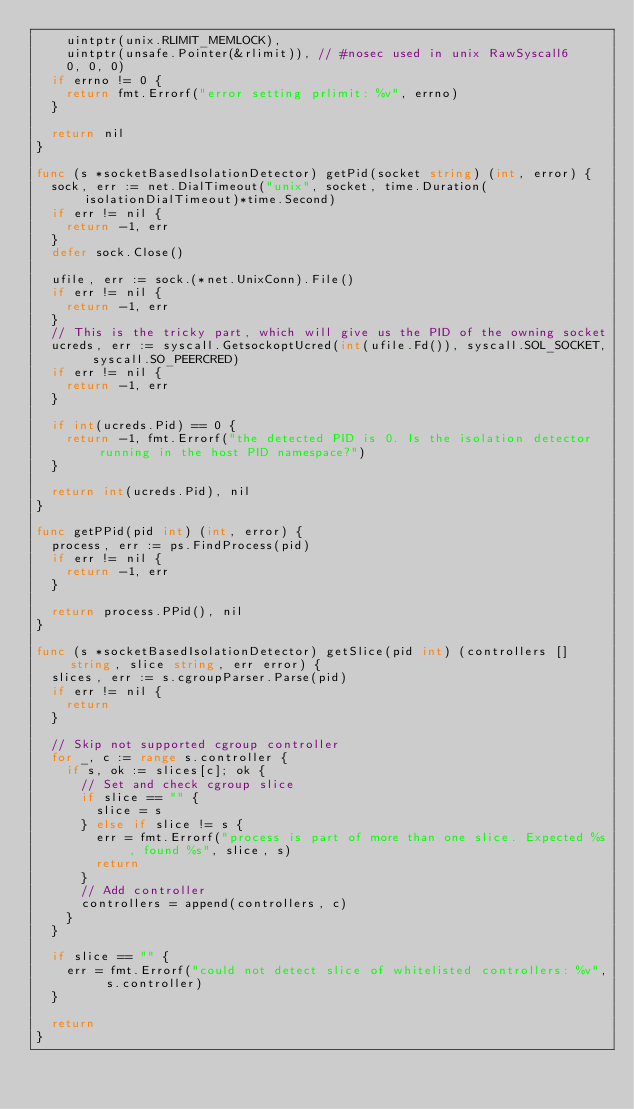Convert code to text. <code><loc_0><loc_0><loc_500><loc_500><_Go_>		uintptr(unix.RLIMIT_MEMLOCK),
		uintptr(unsafe.Pointer(&rlimit)), // #nosec used in unix RawSyscall6
		0, 0, 0)
	if errno != 0 {
		return fmt.Errorf("error setting prlimit: %v", errno)
	}

	return nil
}

func (s *socketBasedIsolationDetector) getPid(socket string) (int, error) {
	sock, err := net.DialTimeout("unix", socket, time.Duration(isolationDialTimeout)*time.Second)
	if err != nil {
		return -1, err
	}
	defer sock.Close()

	ufile, err := sock.(*net.UnixConn).File()
	if err != nil {
		return -1, err
	}
	// This is the tricky part, which will give us the PID of the owning socket
	ucreds, err := syscall.GetsockoptUcred(int(ufile.Fd()), syscall.SOL_SOCKET, syscall.SO_PEERCRED)
	if err != nil {
		return -1, err
	}

	if int(ucreds.Pid) == 0 {
		return -1, fmt.Errorf("the detected PID is 0. Is the isolation detector running in the host PID namespace?")
	}

	return int(ucreds.Pid), nil
}

func getPPid(pid int) (int, error) {
	process, err := ps.FindProcess(pid)
	if err != nil {
		return -1, err
	}

	return process.PPid(), nil
}

func (s *socketBasedIsolationDetector) getSlice(pid int) (controllers []string, slice string, err error) {
	slices, err := s.cgroupParser.Parse(pid)
	if err != nil {
		return
	}

	// Skip not supported cgroup controller
	for _, c := range s.controller {
		if s, ok := slices[c]; ok {
			// Set and check cgroup slice
			if slice == "" {
				slice = s
			} else if slice != s {
				err = fmt.Errorf("process is part of more than one slice. Expected %s, found %s", slice, s)
				return
			}
			// Add controller
			controllers = append(controllers, c)
		}
	}

	if slice == "" {
		err = fmt.Errorf("could not detect slice of whitelisted controllers: %v", s.controller)
	}

	return
}
</code> 